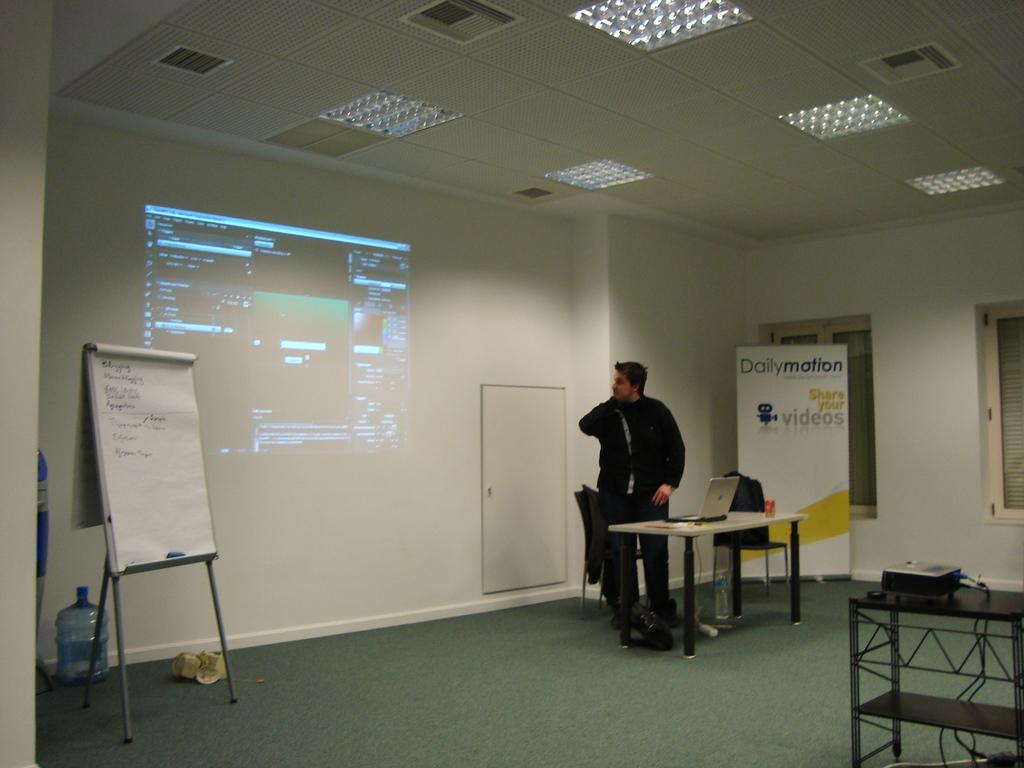<image>
Describe the image concisely. A man in front of a sign for Dailymotion is displaying a presentation. 